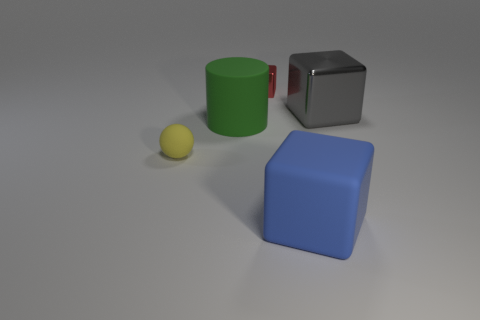There is another object that is made of the same material as the red thing; what is its shape?
Ensure brevity in your answer.  Cube. The large gray metallic thing is what shape?
Make the answer very short. Cube. The rubber thing that is both on the left side of the blue rubber object and on the right side of the yellow rubber object is what color?
Make the answer very short. Green. What is the shape of the red shiny thing that is the same size as the matte sphere?
Ensure brevity in your answer.  Cube. Are there any other big green rubber objects that have the same shape as the green matte object?
Provide a succinct answer. No. Is the material of the large blue object the same as the block on the left side of the big blue block?
Keep it short and to the point. No. The large cube behind the large matte thing that is on the left side of the large rubber thing in front of the tiny yellow rubber thing is what color?
Your answer should be very brief. Gray. There is a green thing that is the same size as the blue rubber object; what is it made of?
Make the answer very short. Rubber. What number of cyan spheres are the same material as the big green thing?
Offer a very short reply. 0. Do the matte cube that is in front of the rubber cylinder and the gray object on the right side of the cylinder have the same size?
Give a very brief answer. Yes. 